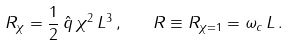Convert formula to latex. <formula><loc_0><loc_0><loc_500><loc_500>R _ { \chi } = \frac { 1 } { 2 } \, \hat { q } \, \chi ^ { 2 } \, L ^ { 3 } \, , \quad R \equiv R _ { \chi = 1 } = \omega _ { c } \, L \, .</formula> 